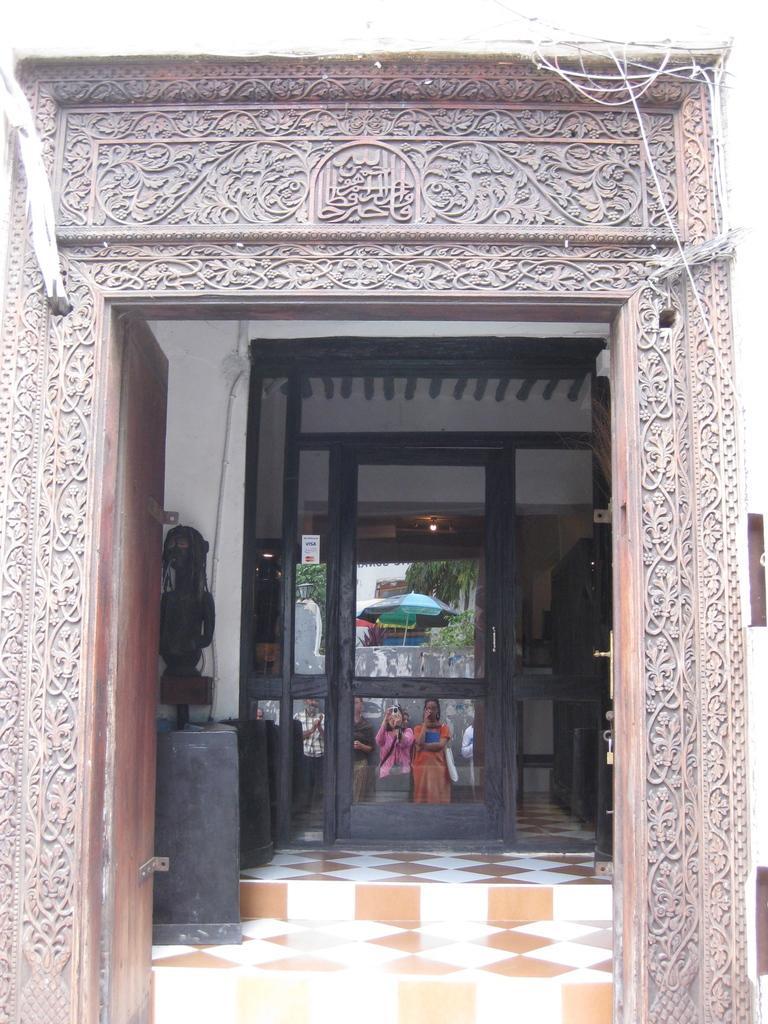Describe this image in one or two sentences. This image looks like an entry of the building, there are some doors, also we can see a few people standing, behind them we can see the wall, umbrella and trees. 